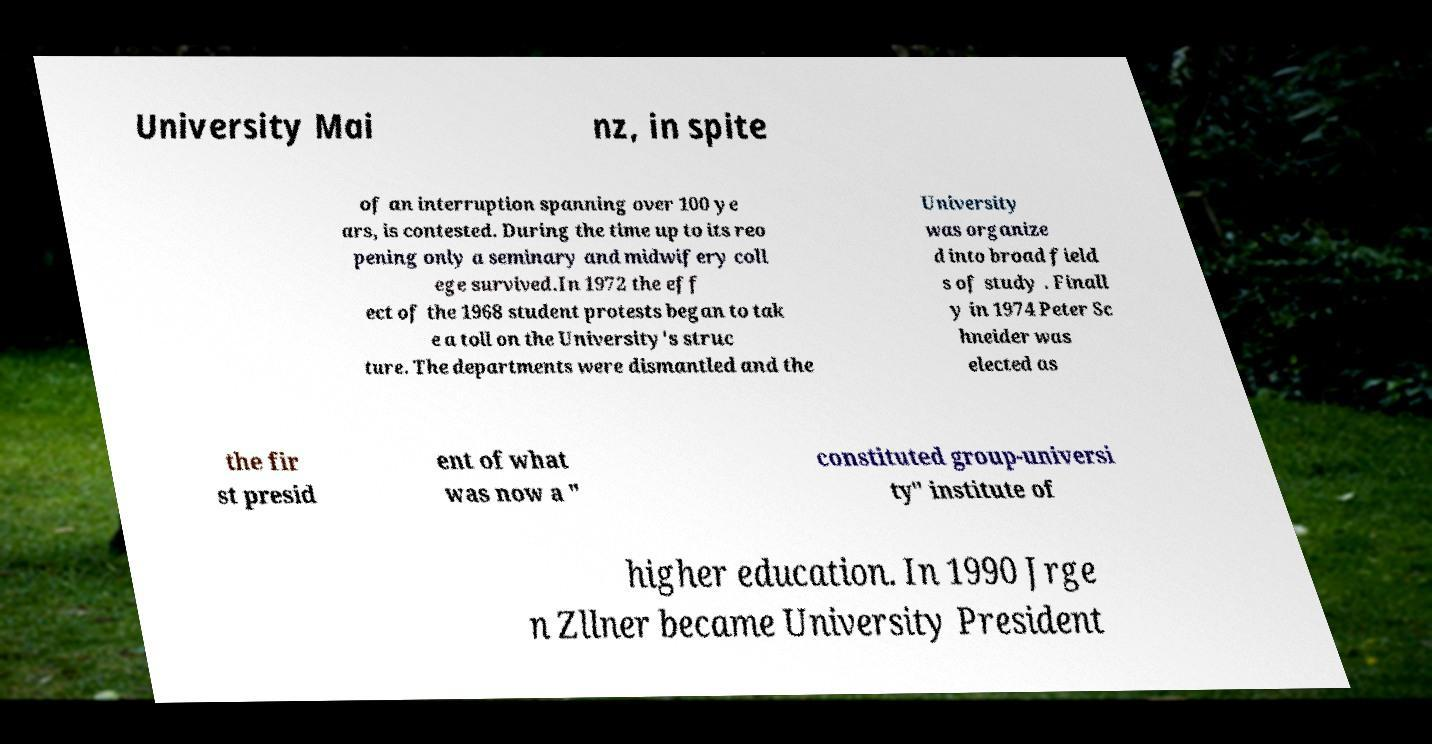Can you read and provide the text displayed in the image?This photo seems to have some interesting text. Can you extract and type it out for me? University Mai nz, in spite of an interruption spanning over 100 ye ars, is contested. During the time up to its reo pening only a seminary and midwifery coll ege survived.In 1972 the eff ect of the 1968 student protests began to tak e a toll on the University's struc ture. The departments were dismantled and the University was organize d into broad field s of study . Finall y in 1974 Peter Sc hneider was elected as the fir st presid ent of what was now a " constituted group-universi ty" institute of higher education. In 1990 Jrge n Zllner became University President 